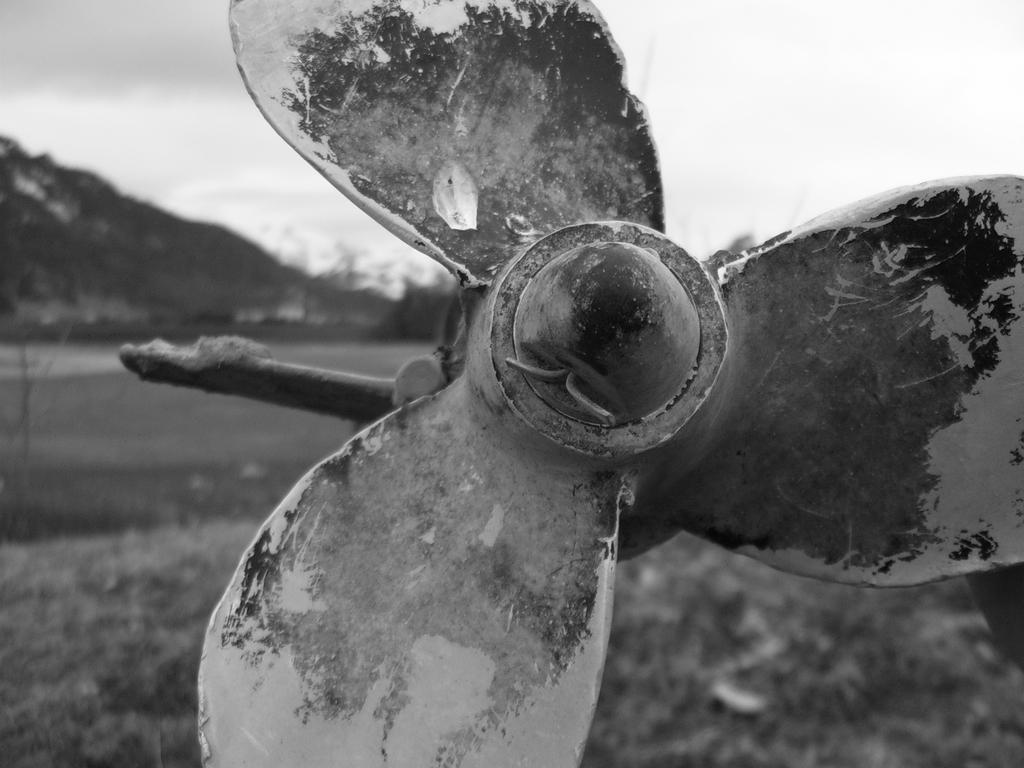In one or two sentences, can you explain what this image depicts? In the center of the image we can see a fan. In the background there are hills and sky. 